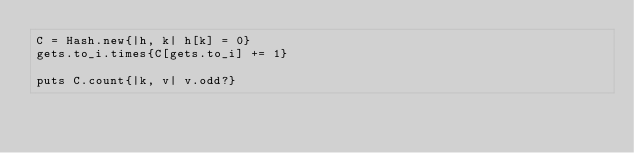<code> <loc_0><loc_0><loc_500><loc_500><_Ruby_>C = Hash.new{|h, k| h[k] = 0}
gets.to_i.times{C[gets.to_i] += 1}

puts C.count{|k, v| v.odd?}
</code> 